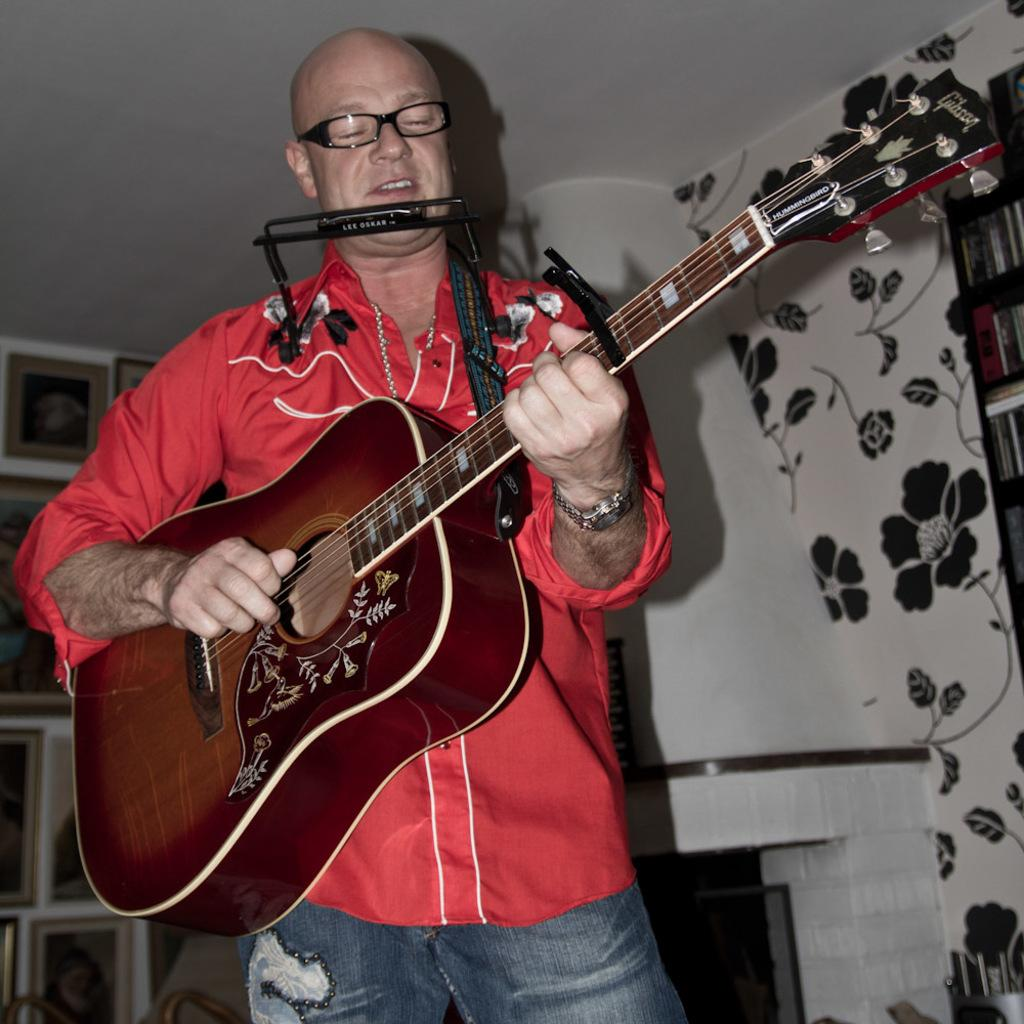What is the main subject of the image? The main subject of the image is a man. What is the man wearing in the image? The man is wearing a red shirt and spectacles. What activity is the man engaged in? The man is playing a guitar. What type of advertisement is displayed on the mailbox in the image? There is no mailbox or advertisement present in the image. How many rabbits can be seen playing with the man in the image? There are no rabbits present in the image; the man is playing a guitar alone. 